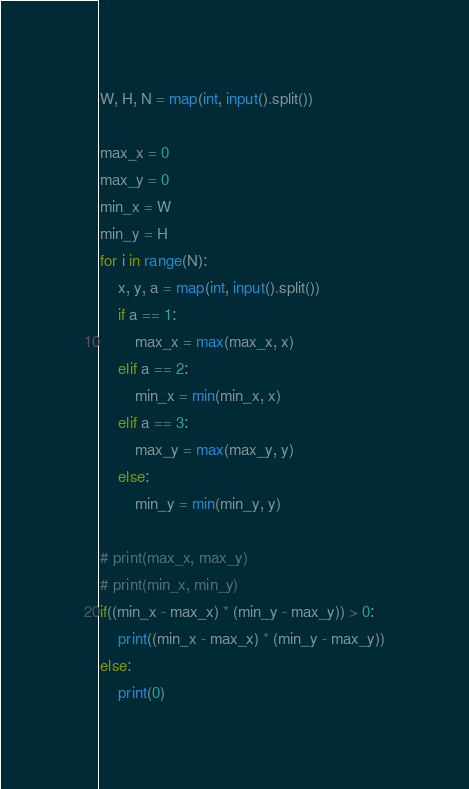<code> <loc_0><loc_0><loc_500><loc_500><_Python_>W, H, N = map(int, input().split())

max_x = 0
max_y = 0
min_x = W
min_y = H
for i in range(N):
    x, y, a = map(int, input().split())
    if a == 1:
        max_x = max(max_x, x)
    elif a == 2:
        min_x = min(min_x, x)
    elif a == 3:
        max_y = max(max_y, y)
    else:
        min_y = min(min_y, y)

# print(max_x, max_y)
# print(min_x, min_y)
if((min_x - max_x) * (min_y - max_y)) > 0:
    print((min_x - max_x) * (min_y - max_y))
else:
    print(0)
</code> 